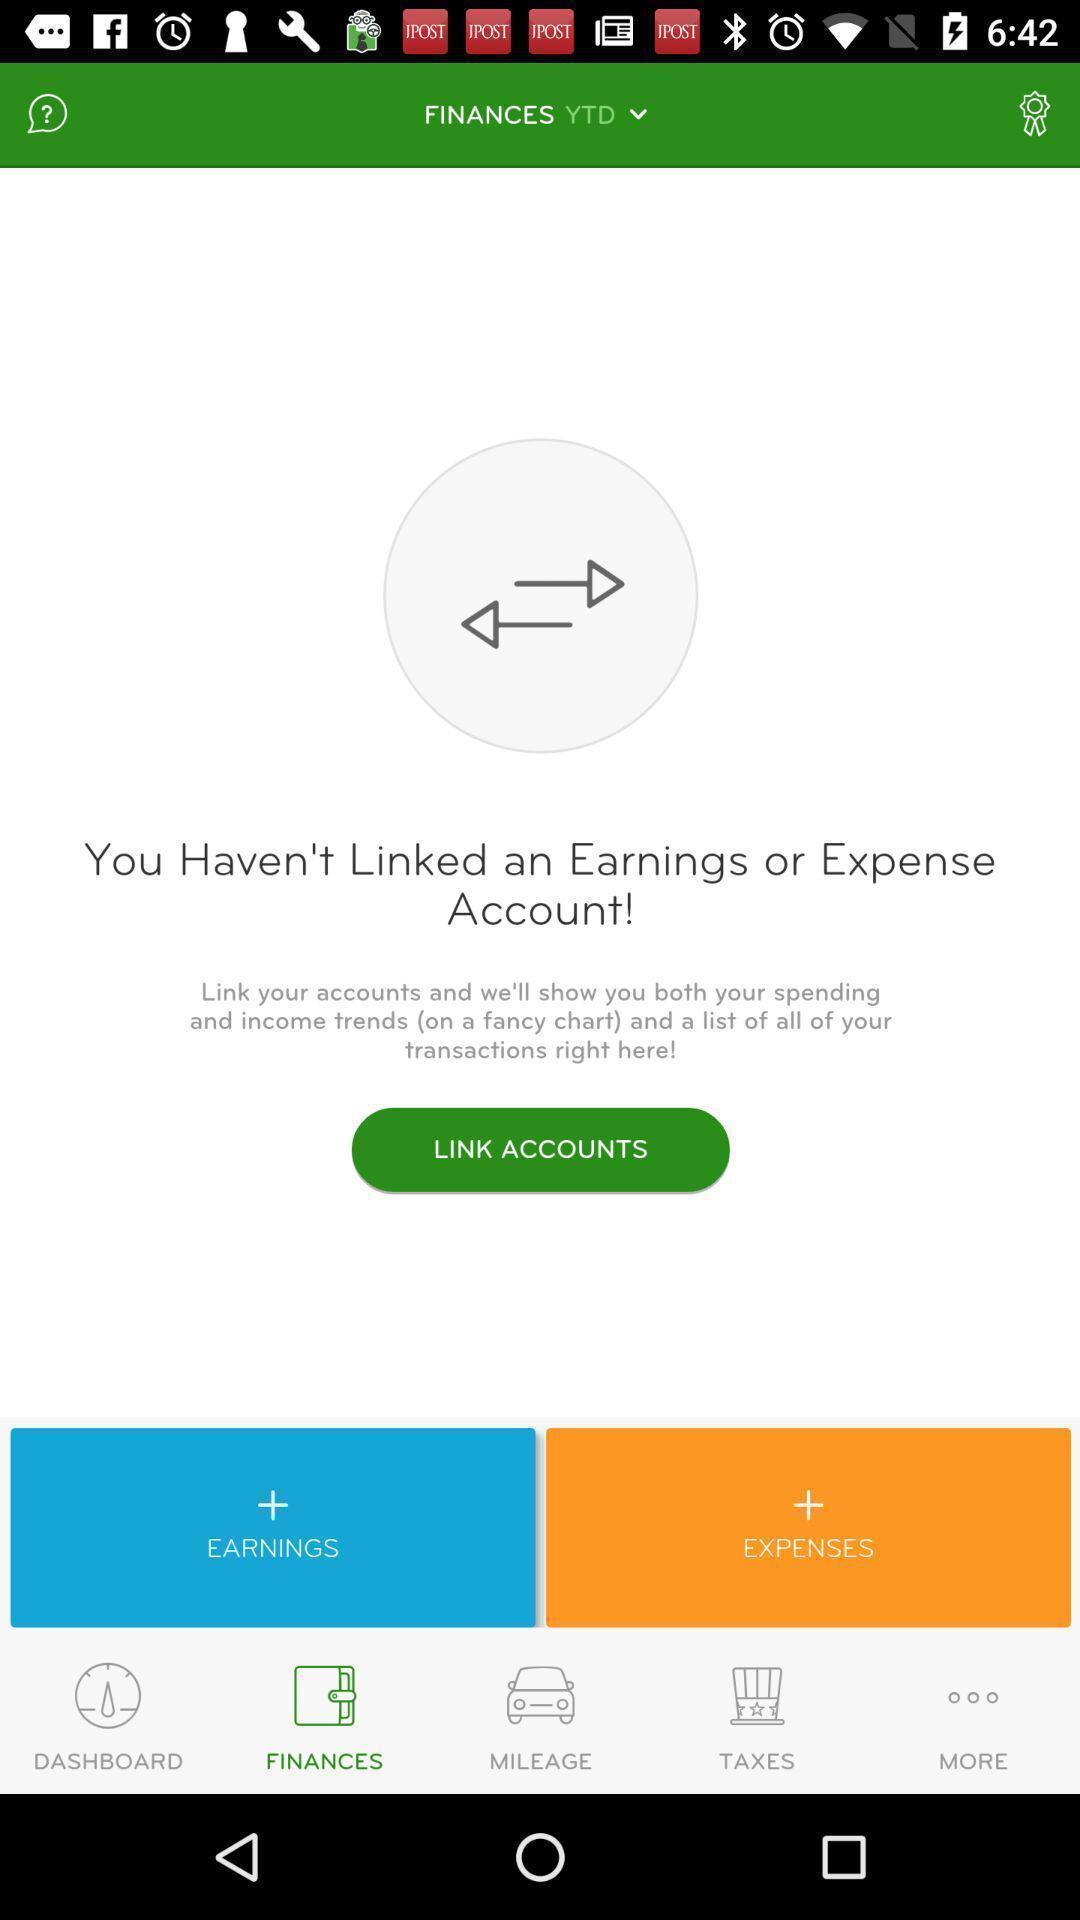Provide a detailed account of this screenshot. Screen shows multiple options in a financial application. 